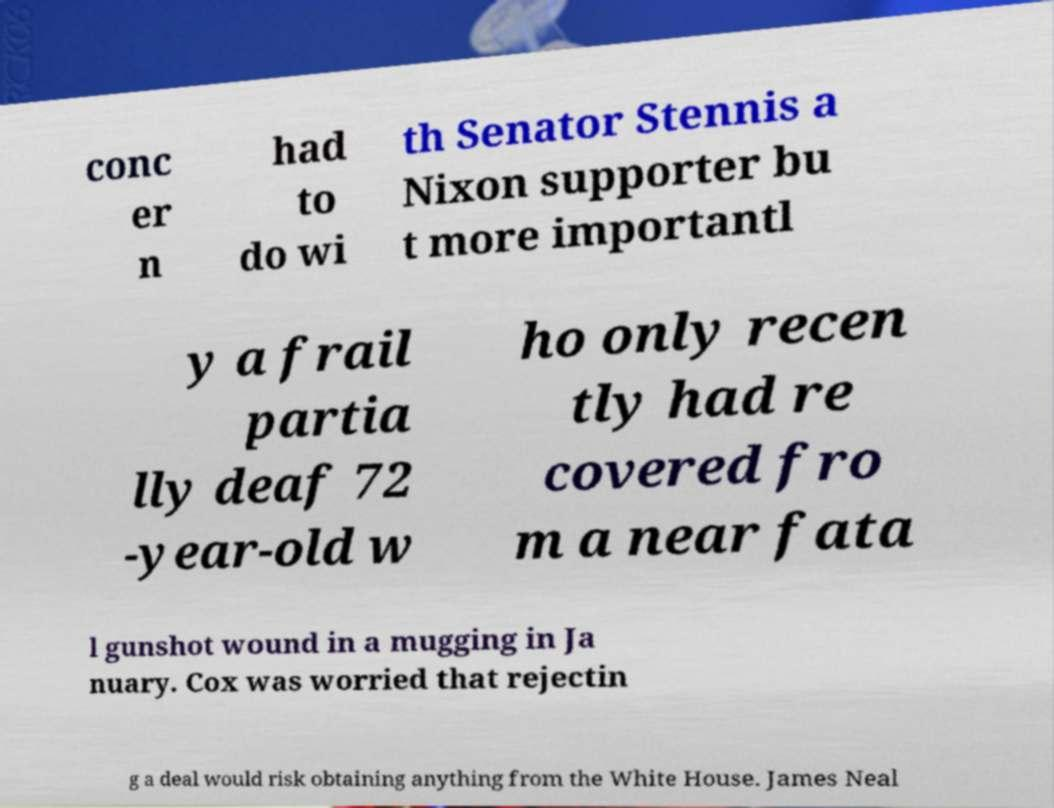For documentation purposes, I need the text within this image transcribed. Could you provide that? conc er n had to do wi th Senator Stennis a Nixon supporter bu t more importantl y a frail partia lly deaf 72 -year-old w ho only recen tly had re covered fro m a near fata l gunshot wound in a mugging in Ja nuary. Cox was worried that rejectin g a deal would risk obtaining anything from the White House. James Neal 